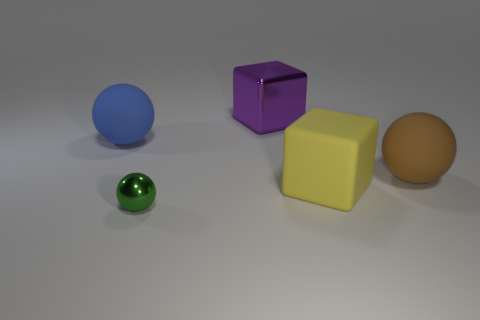How many objects in the image are spherical, and can you describe their appearances? There are two spherical objects in the image. One is blue and positioned on the left side of the image, and the other is smaller and green, located at the very front. 